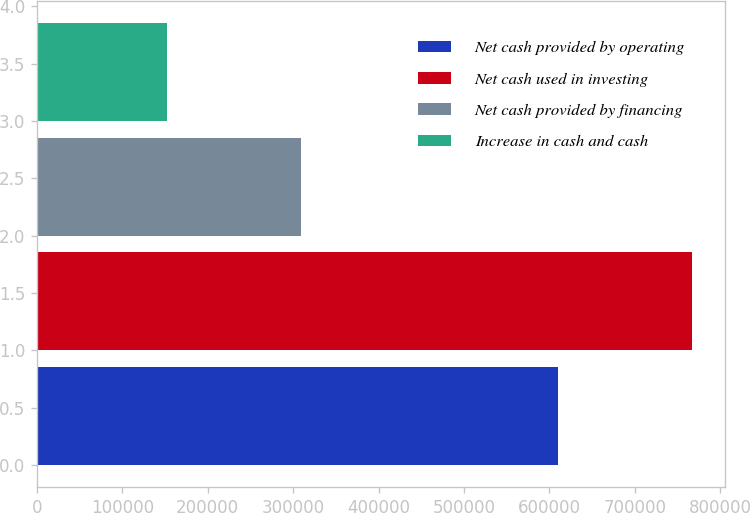Convert chart. <chart><loc_0><loc_0><loc_500><loc_500><bar_chart><fcel>Net cash provided by operating<fcel>Net cash used in investing<fcel>Net cash provided by financing<fcel>Increase in cash and cash<nl><fcel>610082<fcel>767276<fcel>309131<fcel>151937<nl></chart> 